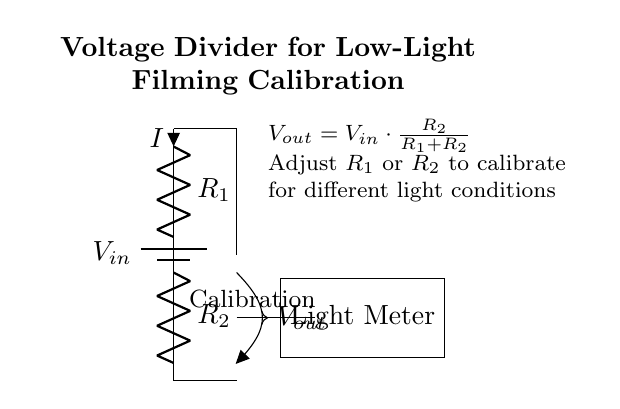What is the input voltage symbol in the circuit? The input voltage is represented by the symbol V_in, which is located at the top of the circuit connected to the battery.
Answer: V_in What are the two resistors labeled in the diagram? The resistors are labeled R_1 and R_2. R_1 is the one connected directly to the input voltage, while R_2 is connected below R_1.
Answer: R_1 and R_2 What does V_out represent? V_out represents the output voltage from the voltage divider circuit, measured across R_2.
Answer: Output voltage How is the output voltage calculated in this circuit? The output voltage, V_out, is calculated using the formula V_out = V_in * (R_2 / (R_1 + R_2)). This formula shows how the output depends on the values of both resistors relative to the total voltage applied.
Answer: V_out = V_in * (R_2 / (R_1 + R_2)) If R_1 is increased while R_2 remains constant, what happens to V_out? If R_1 is increased, the proportion of V_in that is dropped across R_1 increases, which means V_out decreases according to the voltage divider formula. This demonstrates the inverse relationship between R_1 and V_out when R_2 is constant.
Answer: V_out decreases What is the purpose of adjusting R_1 or R_2 in this circuit? By adjusting R_1 or R_2, the user can calibrate the output voltage V_out to correspond to different light levels, which is essential for accurate light meter readings in low-light filming conditions.
Answer: Calibration for light conditions What type of circuit is shown in this diagram? The diagram represents a voltage divider circuit, which is specifically designed to obtain a lower output voltage from a higher input voltage by dividing it across two resistors.
Answer: Voltage divider 